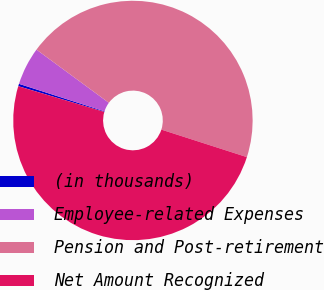Convert chart to OTSL. <chart><loc_0><loc_0><loc_500><loc_500><pie_chart><fcel>(in thousands)<fcel>Employee-related Expenses<fcel>Pension and Post-retirement<fcel>Net Amount Recognized<nl><fcel>0.33%<fcel>5.13%<fcel>44.87%<fcel>49.67%<nl></chart> 